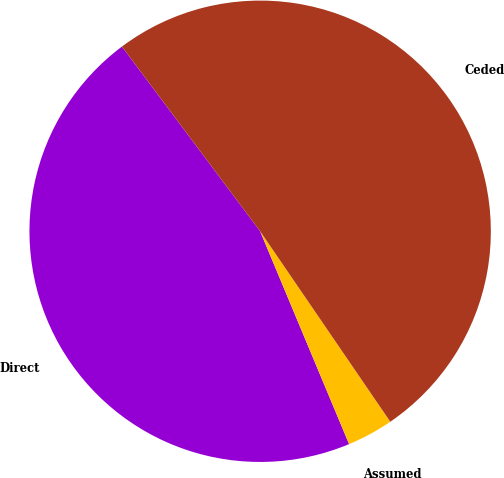Convert chart. <chart><loc_0><loc_0><loc_500><loc_500><pie_chart><fcel>Direct<fcel>Assumed<fcel>Ceded<nl><fcel>46.07%<fcel>3.24%<fcel>50.68%<nl></chart> 